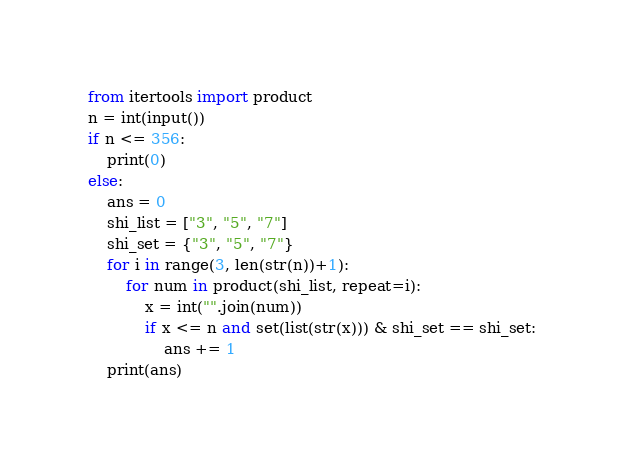<code> <loc_0><loc_0><loc_500><loc_500><_Python_>from itertools import product
n = int(input())
if n <= 356:
	print(0)
else:
	ans = 0
	shi_list = ["3", "5", "7"]
	shi_set = {"3", "5", "7"}
	for i in range(3, len(str(n))+1):
		for num in product(shi_list, repeat=i):
			x = int("".join(num))
			if x <= n and set(list(str(x))) & shi_set == shi_set:
				ans += 1
	print(ans)
</code> 